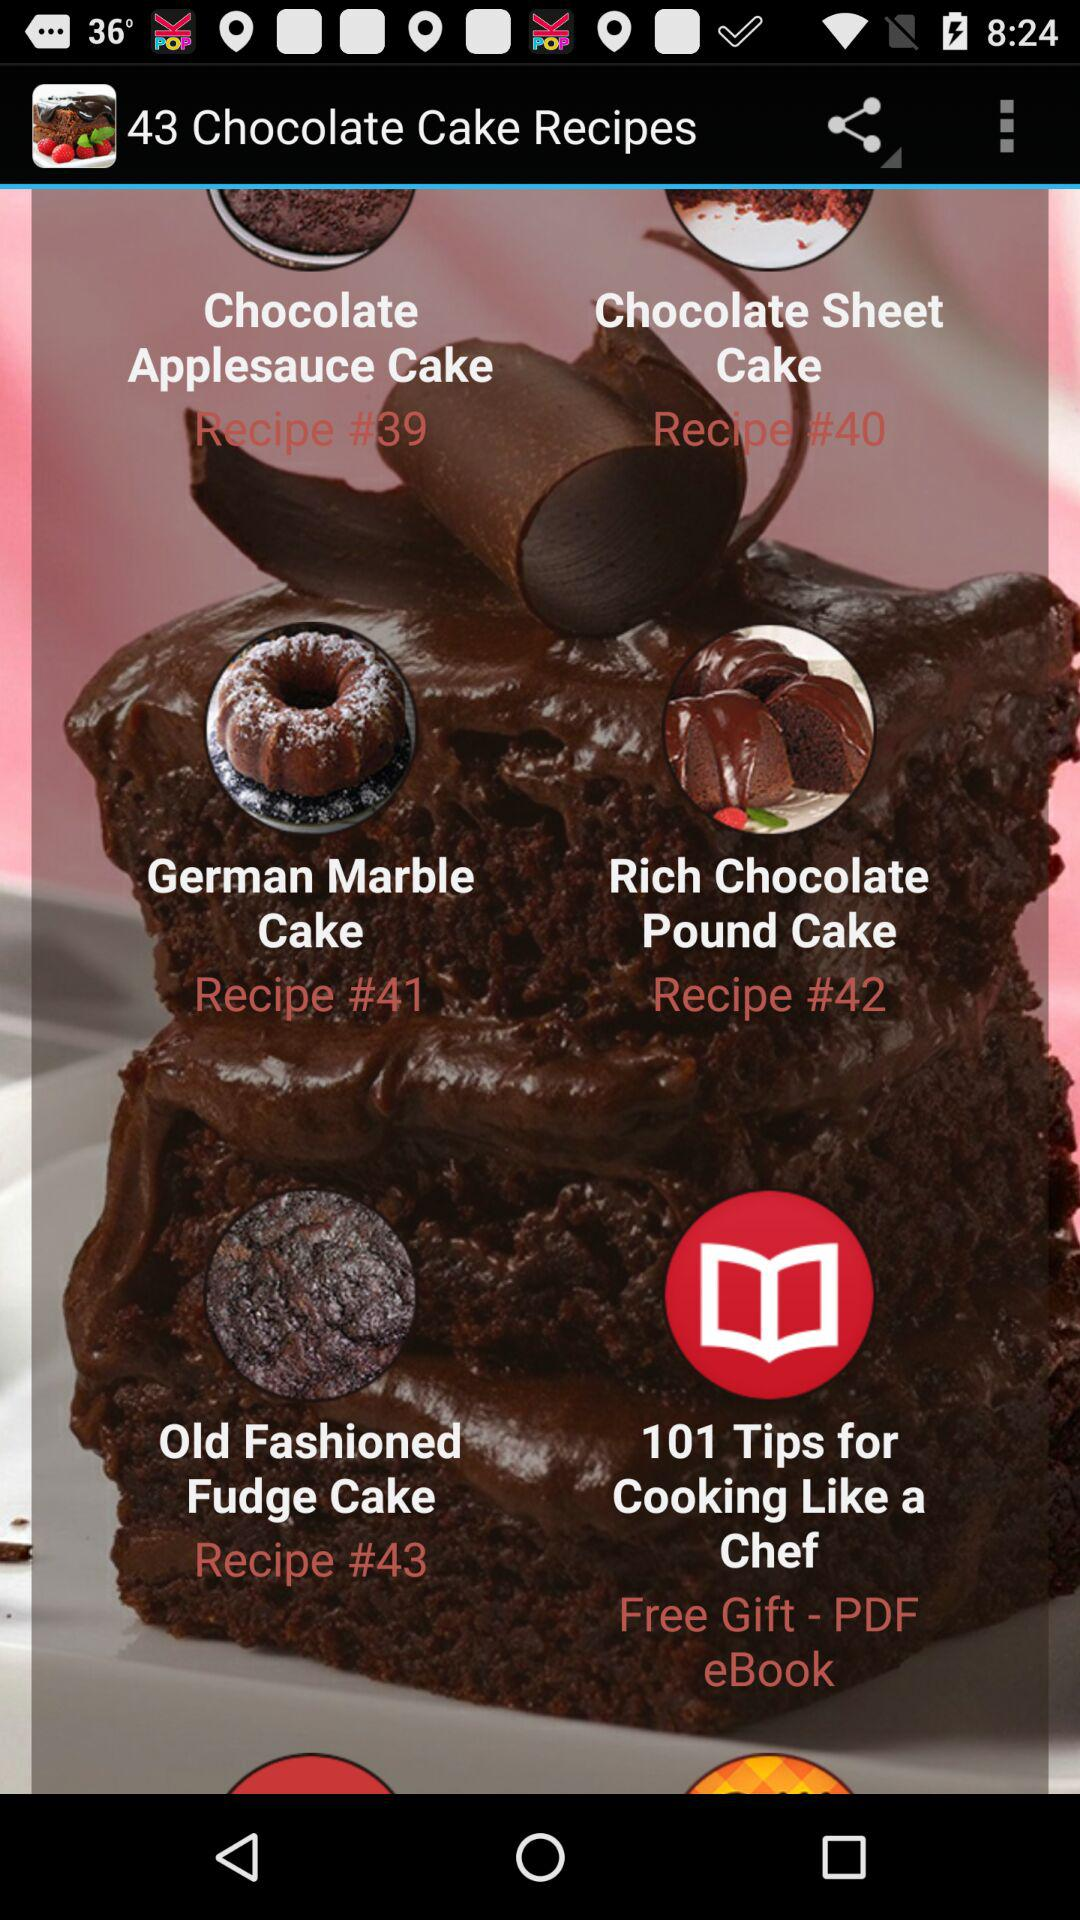What is the gift? The gift is a PDF eBook. 